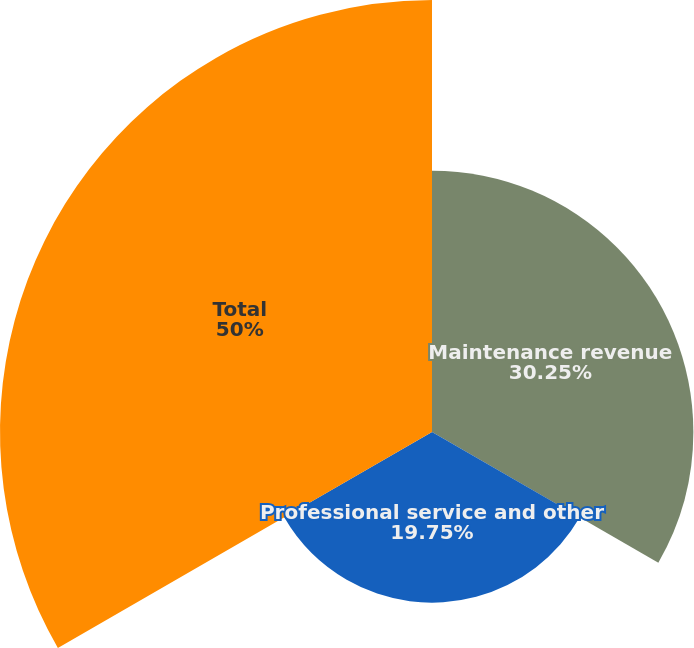Convert chart. <chart><loc_0><loc_0><loc_500><loc_500><pie_chart><fcel>Maintenance revenue<fcel>Professional service and other<fcel>Total<nl><fcel>30.25%<fcel>19.75%<fcel>50.0%<nl></chart> 